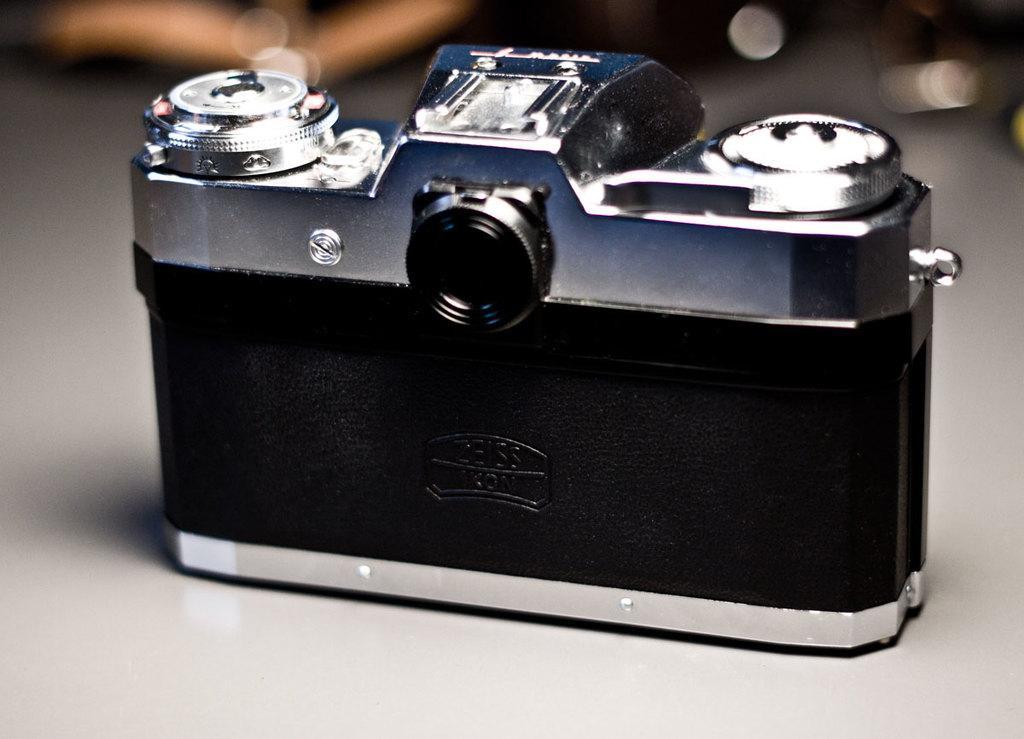Please provide a concise description of this image. In the center of the image there is a camera on the surface. The background of the image is blur. 